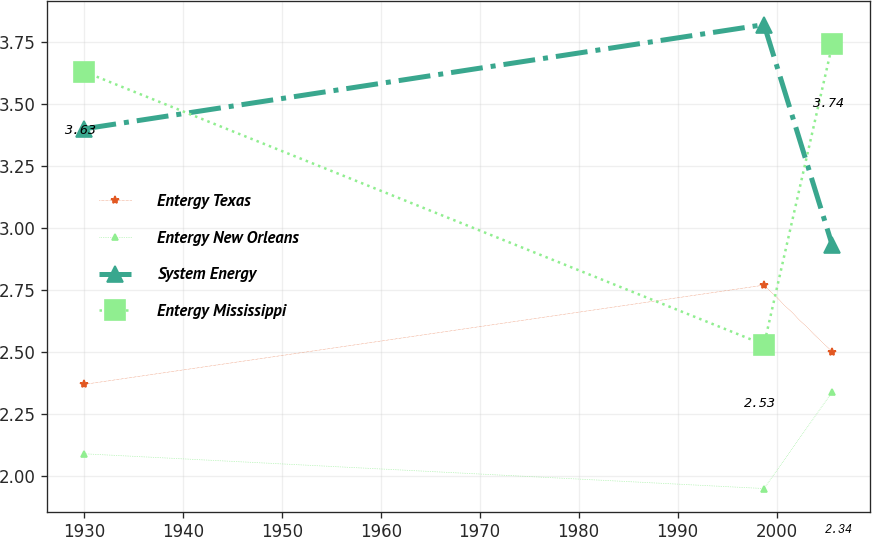Convert chart to OTSL. <chart><loc_0><loc_0><loc_500><loc_500><line_chart><ecel><fcel>Entergy Texas<fcel>Entergy New Orleans<fcel>System Energy<fcel>Entergy Mississippi<nl><fcel>1930.06<fcel>2.37<fcel>2.09<fcel>3.4<fcel>3.63<nl><fcel>1998.73<fcel>2.77<fcel>1.95<fcel>3.82<fcel>2.53<nl><fcel>2005.63<fcel>2.5<fcel>2.34<fcel>2.93<fcel>3.74<nl></chart> 